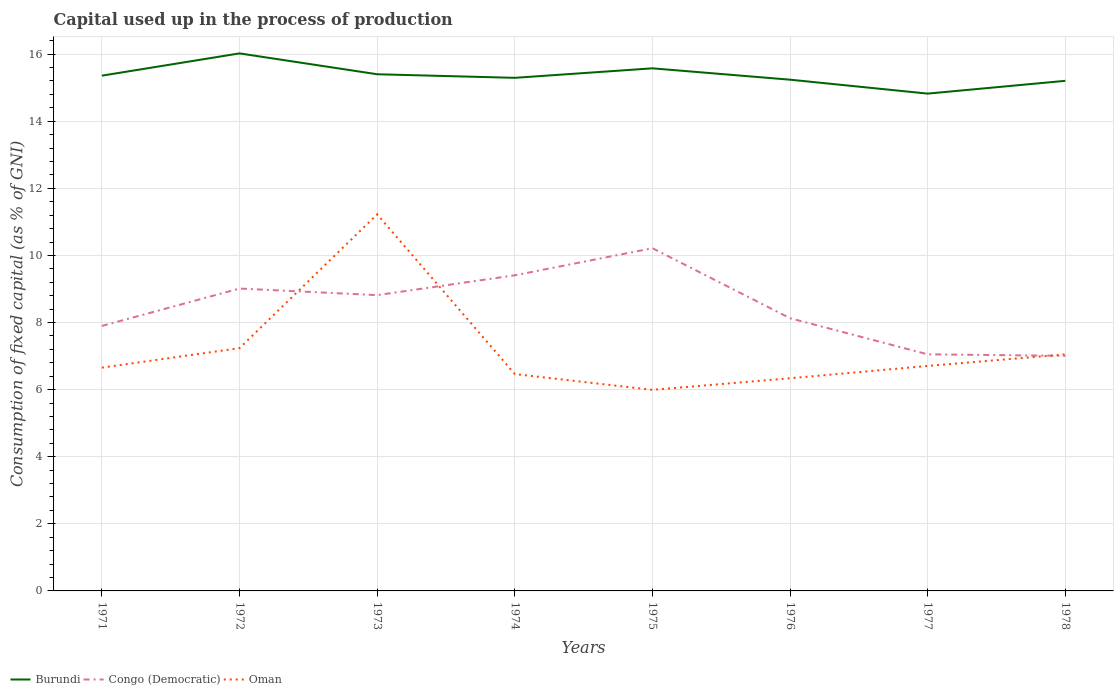How many different coloured lines are there?
Give a very brief answer. 3. Does the line corresponding to Oman intersect with the line corresponding to Congo (Democratic)?
Ensure brevity in your answer.  Yes. Across all years, what is the maximum capital used up in the process of production in Congo (Democratic)?
Give a very brief answer. 7.01. In which year was the capital used up in the process of production in Oman maximum?
Ensure brevity in your answer.  1975. What is the total capital used up in the process of production in Congo (Democratic) in the graph?
Give a very brief answer. -1.4. What is the difference between the highest and the second highest capital used up in the process of production in Congo (Democratic)?
Make the answer very short. 3.21. Is the capital used up in the process of production in Burundi strictly greater than the capital used up in the process of production in Congo (Democratic) over the years?
Provide a short and direct response. No. How many lines are there?
Offer a very short reply. 3. How many years are there in the graph?
Your response must be concise. 8. What is the difference between two consecutive major ticks on the Y-axis?
Offer a very short reply. 2. Are the values on the major ticks of Y-axis written in scientific E-notation?
Provide a succinct answer. No. Does the graph contain any zero values?
Offer a very short reply. No. How many legend labels are there?
Your answer should be compact. 3. How are the legend labels stacked?
Your answer should be compact. Horizontal. What is the title of the graph?
Offer a very short reply. Capital used up in the process of production. What is the label or title of the Y-axis?
Offer a terse response. Consumption of fixed capital (as % of GNI). What is the Consumption of fixed capital (as % of GNI) of Burundi in 1971?
Provide a short and direct response. 15.36. What is the Consumption of fixed capital (as % of GNI) of Congo (Democratic) in 1971?
Provide a short and direct response. 7.9. What is the Consumption of fixed capital (as % of GNI) in Oman in 1971?
Offer a very short reply. 6.66. What is the Consumption of fixed capital (as % of GNI) in Burundi in 1972?
Provide a short and direct response. 16.02. What is the Consumption of fixed capital (as % of GNI) in Congo (Democratic) in 1972?
Provide a short and direct response. 9.01. What is the Consumption of fixed capital (as % of GNI) in Oman in 1972?
Your response must be concise. 7.24. What is the Consumption of fixed capital (as % of GNI) in Burundi in 1973?
Offer a terse response. 15.4. What is the Consumption of fixed capital (as % of GNI) of Congo (Democratic) in 1973?
Your response must be concise. 8.82. What is the Consumption of fixed capital (as % of GNI) of Oman in 1973?
Make the answer very short. 11.23. What is the Consumption of fixed capital (as % of GNI) in Burundi in 1974?
Keep it short and to the point. 15.29. What is the Consumption of fixed capital (as % of GNI) in Congo (Democratic) in 1974?
Your answer should be very brief. 9.41. What is the Consumption of fixed capital (as % of GNI) of Oman in 1974?
Give a very brief answer. 6.46. What is the Consumption of fixed capital (as % of GNI) of Burundi in 1975?
Provide a short and direct response. 15.58. What is the Consumption of fixed capital (as % of GNI) in Congo (Democratic) in 1975?
Your response must be concise. 10.22. What is the Consumption of fixed capital (as % of GNI) in Oman in 1975?
Your answer should be compact. 5.99. What is the Consumption of fixed capital (as % of GNI) of Burundi in 1976?
Your answer should be compact. 15.24. What is the Consumption of fixed capital (as % of GNI) of Congo (Democratic) in 1976?
Provide a succinct answer. 8.13. What is the Consumption of fixed capital (as % of GNI) of Oman in 1976?
Your answer should be very brief. 6.34. What is the Consumption of fixed capital (as % of GNI) of Burundi in 1977?
Keep it short and to the point. 14.82. What is the Consumption of fixed capital (as % of GNI) in Congo (Democratic) in 1977?
Your answer should be very brief. 7.05. What is the Consumption of fixed capital (as % of GNI) of Oman in 1977?
Give a very brief answer. 6.71. What is the Consumption of fixed capital (as % of GNI) in Burundi in 1978?
Provide a succinct answer. 15.2. What is the Consumption of fixed capital (as % of GNI) of Congo (Democratic) in 1978?
Provide a succinct answer. 7.01. What is the Consumption of fixed capital (as % of GNI) of Oman in 1978?
Keep it short and to the point. 7.05. Across all years, what is the maximum Consumption of fixed capital (as % of GNI) in Burundi?
Ensure brevity in your answer.  16.02. Across all years, what is the maximum Consumption of fixed capital (as % of GNI) of Congo (Democratic)?
Keep it short and to the point. 10.22. Across all years, what is the maximum Consumption of fixed capital (as % of GNI) of Oman?
Offer a terse response. 11.23. Across all years, what is the minimum Consumption of fixed capital (as % of GNI) in Burundi?
Your response must be concise. 14.82. Across all years, what is the minimum Consumption of fixed capital (as % of GNI) of Congo (Democratic)?
Your answer should be very brief. 7.01. Across all years, what is the minimum Consumption of fixed capital (as % of GNI) of Oman?
Your answer should be compact. 5.99. What is the total Consumption of fixed capital (as % of GNI) of Burundi in the graph?
Offer a very short reply. 122.92. What is the total Consumption of fixed capital (as % of GNI) of Congo (Democratic) in the graph?
Your response must be concise. 67.54. What is the total Consumption of fixed capital (as % of GNI) of Oman in the graph?
Your answer should be compact. 57.67. What is the difference between the Consumption of fixed capital (as % of GNI) of Burundi in 1971 and that in 1972?
Provide a succinct answer. -0.66. What is the difference between the Consumption of fixed capital (as % of GNI) in Congo (Democratic) in 1971 and that in 1972?
Ensure brevity in your answer.  -1.11. What is the difference between the Consumption of fixed capital (as % of GNI) in Oman in 1971 and that in 1972?
Give a very brief answer. -0.58. What is the difference between the Consumption of fixed capital (as % of GNI) in Burundi in 1971 and that in 1973?
Provide a succinct answer. -0.04. What is the difference between the Consumption of fixed capital (as % of GNI) in Congo (Democratic) in 1971 and that in 1973?
Offer a terse response. -0.92. What is the difference between the Consumption of fixed capital (as % of GNI) of Oman in 1971 and that in 1973?
Keep it short and to the point. -4.57. What is the difference between the Consumption of fixed capital (as % of GNI) in Burundi in 1971 and that in 1974?
Provide a short and direct response. 0.06. What is the difference between the Consumption of fixed capital (as % of GNI) of Congo (Democratic) in 1971 and that in 1974?
Keep it short and to the point. -1.51. What is the difference between the Consumption of fixed capital (as % of GNI) of Oman in 1971 and that in 1974?
Provide a short and direct response. 0.19. What is the difference between the Consumption of fixed capital (as % of GNI) of Burundi in 1971 and that in 1975?
Ensure brevity in your answer.  -0.22. What is the difference between the Consumption of fixed capital (as % of GNI) in Congo (Democratic) in 1971 and that in 1975?
Your response must be concise. -2.32. What is the difference between the Consumption of fixed capital (as % of GNI) in Oman in 1971 and that in 1975?
Keep it short and to the point. 0.66. What is the difference between the Consumption of fixed capital (as % of GNI) of Burundi in 1971 and that in 1976?
Your response must be concise. 0.12. What is the difference between the Consumption of fixed capital (as % of GNI) of Congo (Democratic) in 1971 and that in 1976?
Ensure brevity in your answer.  -0.23. What is the difference between the Consumption of fixed capital (as % of GNI) of Oman in 1971 and that in 1976?
Make the answer very short. 0.32. What is the difference between the Consumption of fixed capital (as % of GNI) of Burundi in 1971 and that in 1977?
Your answer should be compact. 0.54. What is the difference between the Consumption of fixed capital (as % of GNI) of Congo (Democratic) in 1971 and that in 1977?
Give a very brief answer. 0.85. What is the difference between the Consumption of fixed capital (as % of GNI) of Oman in 1971 and that in 1977?
Give a very brief answer. -0.05. What is the difference between the Consumption of fixed capital (as % of GNI) in Burundi in 1971 and that in 1978?
Make the answer very short. 0.15. What is the difference between the Consumption of fixed capital (as % of GNI) of Congo (Democratic) in 1971 and that in 1978?
Offer a terse response. 0.89. What is the difference between the Consumption of fixed capital (as % of GNI) of Oman in 1971 and that in 1978?
Give a very brief answer. -0.4. What is the difference between the Consumption of fixed capital (as % of GNI) of Burundi in 1972 and that in 1973?
Ensure brevity in your answer.  0.62. What is the difference between the Consumption of fixed capital (as % of GNI) in Congo (Democratic) in 1972 and that in 1973?
Provide a short and direct response. 0.2. What is the difference between the Consumption of fixed capital (as % of GNI) of Oman in 1972 and that in 1973?
Offer a terse response. -3.99. What is the difference between the Consumption of fixed capital (as % of GNI) of Burundi in 1972 and that in 1974?
Your response must be concise. 0.73. What is the difference between the Consumption of fixed capital (as % of GNI) of Congo (Democratic) in 1972 and that in 1974?
Offer a terse response. -0.39. What is the difference between the Consumption of fixed capital (as % of GNI) in Oman in 1972 and that in 1974?
Make the answer very short. 0.77. What is the difference between the Consumption of fixed capital (as % of GNI) of Burundi in 1972 and that in 1975?
Make the answer very short. 0.45. What is the difference between the Consumption of fixed capital (as % of GNI) of Congo (Democratic) in 1972 and that in 1975?
Keep it short and to the point. -1.2. What is the difference between the Consumption of fixed capital (as % of GNI) of Oman in 1972 and that in 1975?
Give a very brief answer. 1.24. What is the difference between the Consumption of fixed capital (as % of GNI) of Burundi in 1972 and that in 1976?
Keep it short and to the point. 0.78. What is the difference between the Consumption of fixed capital (as % of GNI) in Congo (Democratic) in 1972 and that in 1976?
Keep it short and to the point. 0.89. What is the difference between the Consumption of fixed capital (as % of GNI) of Oman in 1972 and that in 1976?
Your response must be concise. 0.9. What is the difference between the Consumption of fixed capital (as % of GNI) of Burundi in 1972 and that in 1977?
Provide a succinct answer. 1.2. What is the difference between the Consumption of fixed capital (as % of GNI) of Congo (Democratic) in 1972 and that in 1977?
Ensure brevity in your answer.  1.96. What is the difference between the Consumption of fixed capital (as % of GNI) in Oman in 1972 and that in 1977?
Provide a succinct answer. 0.53. What is the difference between the Consumption of fixed capital (as % of GNI) of Burundi in 1972 and that in 1978?
Offer a very short reply. 0.82. What is the difference between the Consumption of fixed capital (as % of GNI) in Congo (Democratic) in 1972 and that in 1978?
Offer a terse response. 2.01. What is the difference between the Consumption of fixed capital (as % of GNI) in Oman in 1972 and that in 1978?
Provide a succinct answer. 0.19. What is the difference between the Consumption of fixed capital (as % of GNI) in Burundi in 1973 and that in 1974?
Keep it short and to the point. 0.11. What is the difference between the Consumption of fixed capital (as % of GNI) of Congo (Democratic) in 1973 and that in 1974?
Keep it short and to the point. -0.59. What is the difference between the Consumption of fixed capital (as % of GNI) in Oman in 1973 and that in 1974?
Make the answer very short. 4.76. What is the difference between the Consumption of fixed capital (as % of GNI) in Burundi in 1973 and that in 1975?
Ensure brevity in your answer.  -0.18. What is the difference between the Consumption of fixed capital (as % of GNI) in Congo (Democratic) in 1973 and that in 1975?
Give a very brief answer. -1.4. What is the difference between the Consumption of fixed capital (as % of GNI) in Oman in 1973 and that in 1975?
Your answer should be very brief. 5.23. What is the difference between the Consumption of fixed capital (as % of GNI) in Burundi in 1973 and that in 1976?
Your response must be concise. 0.16. What is the difference between the Consumption of fixed capital (as % of GNI) of Congo (Democratic) in 1973 and that in 1976?
Offer a very short reply. 0.69. What is the difference between the Consumption of fixed capital (as % of GNI) in Oman in 1973 and that in 1976?
Your response must be concise. 4.89. What is the difference between the Consumption of fixed capital (as % of GNI) in Burundi in 1973 and that in 1977?
Keep it short and to the point. 0.58. What is the difference between the Consumption of fixed capital (as % of GNI) in Congo (Democratic) in 1973 and that in 1977?
Your response must be concise. 1.76. What is the difference between the Consumption of fixed capital (as % of GNI) of Oman in 1973 and that in 1977?
Ensure brevity in your answer.  4.52. What is the difference between the Consumption of fixed capital (as % of GNI) of Burundi in 1973 and that in 1978?
Provide a short and direct response. 0.2. What is the difference between the Consumption of fixed capital (as % of GNI) of Congo (Democratic) in 1973 and that in 1978?
Offer a very short reply. 1.81. What is the difference between the Consumption of fixed capital (as % of GNI) in Oman in 1973 and that in 1978?
Provide a short and direct response. 4.17. What is the difference between the Consumption of fixed capital (as % of GNI) of Burundi in 1974 and that in 1975?
Provide a succinct answer. -0.28. What is the difference between the Consumption of fixed capital (as % of GNI) of Congo (Democratic) in 1974 and that in 1975?
Your response must be concise. -0.81. What is the difference between the Consumption of fixed capital (as % of GNI) of Oman in 1974 and that in 1975?
Your answer should be compact. 0.47. What is the difference between the Consumption of fixed capital (as % of GNI) of Burundi in 1974 and that in 1976?
Give a very brief answer. 0.06. What is the difference between the Consumption of fixed capital (as % of GNI) in Congo (Democratic) in 1974 and that in 1976?
Your response must be concise. 1.28. What is the difference between the Consumption of fixed capital (as % of GNI) in Oman in 1974 and that in 1976?
Keep it short and to the point. 0.12. What is the difference between the Consumption of fixed capital (as % of GNI) of Burundi in 1974 and that in 1977?
Give a very brief answer. 0.47. What is the difference between the Consumption of fixed capital (as % of GNI) in Congo (Democratic) in 1974 and that in 1977?
Your answer should be very brief. 2.36. What is the difference between the Consumption of fixed capital (as % of GNI) of Oman in 1974 and that in 1977?
Offer a very short reply. -0.24. What is the difference between the Consumption of fixed capital (as % of GNI) in Burundi in 1974 and that in 1978?
Keep it short and to the point. 0.09. What is the difference between the Consumption of fixed capital (as % of GNI) in Congo (Democratic) in 1974 and that in 1978?
Your response must be concise. 2.4. What is the difference between the Consumption of fixed capital (as % of GNI) in Oman in 1974 and that in 1978?
Your answer should be very brief. -0.59. What is the difference between the Consumption of fixed capital (as % of GNI) of Burundi in 1975 and that in 1976?
Offer a terse response. 0.34. What is the difference between the Consumption of fixed capital (as % of GNI) of Congo (Democratic) in 1975 and that in 1976?
Give a very brief answer. 2.09. What is the difference between the Consumption of fixed capital (as % of GNI) in Oman in 1975 and that in 1976?
Make the answer very short. -0.35. What is the difference between the Consumption of fixed capital (as % of GNI) in Burundi in 1975 and that in 1977?
Your answer should be compact. 0.75. What is the difference between the Consumption of fixed capital (as % of GNI) in Congo (Democratic) in 1975 and that in 1977?
Keep it short and to the point. 3.16. What is the difference between the Consumption of fixed capital (as % of GNI) of Oman in 1975 and that in 1977?
Make the answer very short. -0.71. What is the difference between the Consumption of fixed capital (as % of GNI) in Burundi in 1975 and that in 1978?
Your response must be concise. 0.37. What is the difference between the Consumption of fixed capital (as % of GNI) of Congo (Democratic) in 1975 and that in 1978?
Provide a succinct answer. 3.21. What is the difference between the Consumption of fixed capital (as % of GNI) in Oman in 1975 and that in 1978?
Provide a succinct answer. -1.06. What is the difference between the Consumption of fixed capital (as % of GNI) in Burundi in 1976 and that in 1977?
Your response must be concise. 0.41. What is the difference between the Consumption of fixed capital (as % of GNI) in Congo (Democratic) in 1976 and that in 1977?
Your response must be concise. 1.08. What is the difference between the Consumption of fixed capital (as % of GNI) in Oman in 1976 and that in 1977?
Offer a terse response. -0.37. What is the difference between the Consumption of fixed capital (as % of GNI) of Burundi in 1976 and that in 1978?
Ensure brevity in your answer.  0.03. What is the difference between the Consumption of fixed capital (as % of GNI) in Congo (Democratic) in 1976 and that in 1978?
Keep it short and to the point. 1.12. What is the difference between the Consumption of fixed capital (as % of GNI) of Oman in 1976 and that in 1978?
Provide a short and direct response. -0.71. What is the difference between the Consumption of fixed capital (as % of GNI) in Burundi in 1977 and that in 1978?
Make the answer very short. -0.38. What is the difference between the Consumption of fixed capital (as % of GNI) in Congo (Democratic) in 1977 and that in 1978?
Make the answer very short. 0.05. What is the difference between the Consumption of fixed capital (as % of GNI) of Oman in 1977 and that in 1978?
Make the answer very short. -0.35. What is the difference between the Consumption of fixed capital (as % of GNI) of Burundi in 1971 and the Consumption of fixed capital (as % of GNI) of Congo (Democratic) in 1972?
Provide a succinct answer. 6.35. What is the difference between the Consumption of fixed capital (as % of GNI) of Burundi in 1971 and the Consumption of fixed capital (as % of GNI) of Oman in 1972?
Your answer should be very brief. 8.12. What is the difference between the Consumption of fixed capital (as % of GNI) in Congo (Democratic) in 1971 and the Consumption of fixed capital (as % of GNI) in Oman in 1972?
Your response must be concise. 0.66. What is the difference between the Consumption of fixed capital (as % of GNI) of Burundi in 1971 and the Consumption of fixed capital (as % of GNI) of Congo (Democratic) in 1973?
Give a very brief answer. 6.54. What is the difference between the Consumption of fixed capital (as % of GNI) of Burundi in 1971 and the Consumption of fixed capital (as % of GNI) of Oman in 1973?
Make the answer very short. 4.13. What is the difference between the Consumption of fixed capital (as % of GNI) in Congo (Democratic) in 1971 and the Consumption of fixed capital (as % of GNI) in Oman in 1973?
Provide a succinct answer. -3.33. What is the difference between the Consumption of fixed capital (as % of GNI) in Burundi in 1971 and the Consumption of fixed capital (as % of GNI) in Congo (Democratic) in 1974?
Your response must be concise. 5.95. What is the difference between the Consumption of fixed capital (as % of GNI) of Burundi in 1971 and the Consumption of fixed capital (as % of GNI) of Oman in 1974?
Provide a short and direct response. 8.89. What is the difference between the Consumption of fixed capital (as % of GNI) in Congo (Democratic) in 1971 and the Consumption of fixed capital (as % of GNI) in Oman in 1974?
Offer a terse response. 1.43. What is the difference between the Consumption of fixed capital (as % of GNI) in Burundi in 1971 and the Consumption of fixed capital (as % of GNI) in Congo (Democratic) in 1975?
Your answer should be compact. 5.14. What is the difference between the Consumption of fixed capital (as % of GNI) in Burundi in 1971 and the Consumption of fixed capital (as % of GNI) in Oman in 1975?
Give a very brief answer. 9.37. What is the difference between the Consumption of fixed capital (as % of GNI) in Congo (Democratic) in 1971 and the Consumption of fixed capital (as % of GNI) in Oman in 1975?
Give a very brief answer. 1.91. What is the difference between the Consumption of fixed capital (as % of GNI) in Burundi in 1971 and the Consumption of fixed capital (as % of GNI) in Congo (Democratic) in 1976?
Make the answer very short. 7.23. What is the difference between the Consumption of fixed capital (as % of GNI) in Burundi in 1971 and the Consumption of fixed capital (as % of GNI) in Oman in 1976?
Ensure brevity in your answer.  9.02. What is the difference between the Consumption of fixed capital (as % of GNI) in Congo (Democratic) in 1971 and the Consumption of fixed capital (as % of GNI) in Oman in 1976?
Your answer should be compact. 1.56. What is the difference between the Consumption of fixed capital (as % of GNI) in Burundi in 1971 and the Consumption of fixed capital (as % of GNI) in Congo (Democratic) in 1977?
Provide a succinct answer. 8.31. What is the difference between the Consumption of fixed capital (as % of GNI) of Burundi in 1971 and the Consumption of fixed capital (as % of GNI) of Oman in 1977?
Keep it short and to the point. 8.65. What is the difference between the Consumption of fixed capital (as % of GNI) in Congo (Democratic) in 1971 and the Consumption of fixed capital (as % of GNI) in Oman in 1977?
Provide a short and direct response. 1.19. What is the difference between the Consumption of fixed capital (as % of GNI) in Burundi in 1971 and the Consumption of fixed capital (as % of GNI) in Congo (Democratic) in 1978?
Make the answer very short. 8.35. What is the difference between the Consumption of fixed capital (as % of GNI) in Burundi in 1971 and the Consumption of fixed capital (as % of GNI) in Oman in 1978?
Ensure brevity in your answer.  8.31. What is the difference between the Consumption of fixed capital (as % of GNI) in Congo (Democratic) in 1971 and the Consumption of fixed capital (as % of GNI) in Oman in 1978?
Offer a terse response. 0.85. What is the difference between the Consumption of fixed capital (as % of GNI) in Burundi in 1972 and the Consumption of fixed capital (as % of GNI) in Congo (Democratic) in 1973?
Offer a terse response. 7.21. What is the difference between the Consumption of fixed capital (as % of GNI) of Burundi in 1972 and the Consumption of fixed capital (as % of GNI) of Oman in 1973?
Give a very brief answer. 4.8. What is the difference between the Consumption of fixed capital (as % of GNI) of Congo (Democratic) in 1972 and the Consumption of fixed capital (as % of GNI) of Oman in 1973?
Your answer should be very brief. -2.21. What is the difference between the Consumption of fixed capital (as % of GNI) in Burundi in 1972 and the Consumption of fixed capital (as % of GNI) in Congo (Democratic) in 1974?
Keep it short and to the point. 6.61. What is the difference between the Consumption of fixed capital (as % of GNI) in Burundi in 1972 and the Consumption of fixed capital (as % of GNI) in Oman in 1974?
Your answer should be compact. 9.56. What is the difference between the Consumption of fixed capital (as % of GNI) of Congo (Democratic) in 1972 and the Consumption of fixed capital (as % of GNI) of Oman in 1974?
Offer a terse response. 2.55. What is the difference between the Consumption of fixed capital (as % of GNI) of Burundi in 1972 and the Consumption of fixed capital (as % of GNI) of Congo (Democratic) in 1975?
Provide a succinct answer. 5.81. What is the difference between the Consumption of fixed capital (as % of GNI) in Burundi in 1972 and the Consumption of fixed capital (as % of GNI) in Oman in 1975?
Offer a terse response. 10.03. What is the difference between the Consumption of fixed capital (as % of GNI) in Congo (Democratic) in 1972 and the Consumption of fixed capital (as % of GNI) in Oman in 1975?
Your answer should be very brief. 3.02. What is the difference between the Consumption of fixed capital (as % of GNI) in Burundi in 1972 and the Consumption of fixed capital (as % of GNI) in Congo (Democratic) in 1976?
Offer a terse response. 7.89. What is the difference between the Consumption of fixed capital (as % of GNI) in Burundi in 1972 and the Consumption of fixed capital (as % of GNI) in Oman in 1976?
Your answer should be compact. 9.68. What is the difference between the Consumption of fixed capital (as % of GNI) in Congo (Democratic) in 1972 and the Consumption of fixed capital (as % of GNI) in Oman in 1976?
Ensure brevity in your answer.  2.67. What is the difference between the Consumption of fixed capital (as % of GNI) in Burundi in 1972 and the Consumption of fixed capital (as % of GNI) in Congo (Democratic) in 1977?
Give a very brief answer. 8.97. What is the difference between the Consumption of fixed capital (as % of GNI) of Burundi in 1972 and the Consumption of fixed capital (as % of GNI) of Oman in 1977?
Your answer should be very brief. 9.32. What is the difference between the Consumption of fixed capital (as % of GNI) in Congo (Democratic) in 1972 and the Consumption of fixed capital (as % of GNI) in Oman in 1977?
Keep it short and to the point. 2.31. What is the difference between the Consumption of fixed capital (as % of GNI) in Burundi in 1972 and the Consumption of fixed capital (as % of GNI) in Congo (Democratic) in 1978?
Your response must be concise. 9.02. What is the difference between the Consumption of fixed capital (as % of GNI) in Burundi in 1972 and the Consumption of fixed capital (as % of GNI) in Oman in 1978?
Your answer should be compact. 8.97. What is the difference between the Consumption of fixed capital (as % of GNI) of Congo (Democratic) in 1972 and the Consumption of fixed capital (as % of GNI) of Oman in 1978?
Your answer should be very brief. 1.96. What is the difference between the Consumption of fixed capital (as % of GNI) of Burundi in 1973 and the Consumption of fixed capital (as % of GNI) of Congo (Democratic) in 1974?
Ensure brevity in your answer.  5.99. What is the difference between the Consumption of fixed capital (as % of GNI) in Burundi in 1973 and the Consumption of fixed capital (as % of GNI) in Oman in 1974?
Provide a short and direct response. 8.94. What is the difference between the Consumption of fixed capital (as % of GNI) in Congo (Democratic) in 1973 and the Consumption of fixed capital (as % of GNI) in Oman in 1974?
Your answer should be compact. 2.35. What is the difference between the Consumption of fixed capital (as % of GNI) in Burundi in 1973 and the Consumption of fixed capital (as % of GNI) in Congo (Democratic) in 1975?
Your answer should be very brief. 5.19. What is the difference between the Consumption of fixed capital (as % of GNI) of Burundi in 1973 and the Consumption of fixed capital (as % of GNI) of Oman in 1975?
Keep it short and to the point. 9.41. What is the difference between the Consumption of fixed capital (as % of GNI) in Congo (Democratic) in 1973 and the Consumption of fixed capital (as % of GNI) in Oman in 1975?
Your answer should be compact. 2.82. What is the difference between the Consumption of fixed capital (as % of GNI) of Burundi in 1973 and the Consumption of fixed capital (as % of GNI) of Congo (Democratic) in 1976?
Provide a short and direct response. 7.27. What is the difference between the Consumption of fixed capital (as % of GNI) of Burundi in 1973 and the Consumption of fixed capital (as % of GNI) of Oman in 1976?
Offer a very short reply. 9.06. What is the difference between the Consumption of fixed capital (as % of GNI) in Congo (Democratic) in 1973 and the Consumption of fixed capital (as % of GNI) in Oman in 1976?
Your answer should be compact. 2.48. What is the difference between the Consumption of fixed capital (as % of GNI) in Burundi in 1973 and the Consumption of fixed capital (as % of GNI) in Congo (Democratic) in 1977?
Ensure brevity in your answer.  8.35. What is the difference between the Consumption of fixed capital (as % of GNI) of Burundi in 1973 and the Consumption of fixed capital (as % of GNI) of Oman in 1977?
Offer a terse response. 8.7. What is the difference between the Consumption of fixed capital (as % of GNI) in Congo (Democratic) in 1973 and the Consumption of fixed capital (as % of GNI) in Oman in 1977?
Your answer should be compact. 2.11. What is the difference between the Consumption of fixed capital (as % of GNI) in Burundi in 1973 and the Consumption of fixed capital (as % of GNI) in Congo (Democratic) in 1978?
Offer a terse response. 8.39. What is the difference between the Consumption of fixed capital (as % of GNI) of Burundi in 1973 and the Consumption of fixed capital (as % of GNI) of Oman in 1978?
Keep it short and to the point. 8.35. What is the difference between the Consumption of fixed capital (as % of GNI) of Congo (Democratic) in 1973 and the Consumption of fixed capital (as % of GNI) of Oman in 1978?
Ensure brevity in your answer.  1.77. What is the difference between the Consumption of fixed capital (as % of GNI) of Burundi in 1974 and the Consumption of fixed capital (as % of GNI) of Congo (Democratic) in 1975?
Ensure brevity in your answer.  5.08. What is the difference between the Consumption of fixed capital (as % of GNI) of Burundi in 1974 and the Consumption of fixed capital (as % of GNI) of Oman in 1975?
Offer a terse response. 9.3. What is the difference between the Consumption of fixed capital (as % of GNI) in Congo (Democratic) in 1974 and the Consumption of fixed capital (as % of GNI) in Oman in 1975?
Your answer should be very brief. 3.41. What is the difference between the Consumption of fixed capital (as % of GNI) in Burundi in 1974 and the Consumption of fixed capital (as % of GNI) in Congo (Democratic) in 1976?
Ensure brevity in your answer.  7.17. What is the difference between the Consumption of fixed capital (as % of GNI) in Burundi in 1974 and the Consumption of fixed capital (as % of GNI) in Oman in 1976?
Your answer should be compact. 8.95. What is the difference between the Consumption of fixed capital (as % of GNI) in Congo (Democratic) in 1974 and the Consumption of fixed capital (as % of GNI) in Oman in 1976?
Your answer should be compact. 3.07. What is the difference between the Consumption of fixed capital (as % of GNI) in Burundi in 1974 and the Consumption of fixed capital (as % of GNI) in Congo (Democratic) in 1977?
Provide a succinct answer. 8.24. What is the difference between the Consumption of fixed capital (as % of GNI) in Burundi in 1974 and the Consumption of fixed capital (as % of GNI) in Oman in 1977?
Offer a very short reply. 8.59. What is the difference between the Consumption of fixed capital (as % of GNI) in Congo (Democratic) in 1974 and the Consumption of fixed capital (as % of GNI) in Oman in 1977?
Your answer should be very brief. 2.7. What is the difference between the Consumption of fixed capital (as % of GNI) in Burundi in 1974 and the Consumption of fixed capital (as % of GNI) in Congo (Democratic) in 1978?
Offer a very short reply. 8.29. What is the difference between the Consumption of fixed capital (as % of GNI) of Burundi in 1974 and the Consumption of fixed capital (as % of GNI) of Oman in 1978?
Your response must be concise. 8.24. What is the difference between the Consumption of fixed capital (as % of GNI) of Congo (Democratic) in 1974 and the Consumption of fixed capital (as % of GNI) of Oman in 1978?
Your answer should be very brief. 2.36. What is the difference between the Consumption of fixed capital (as % of GNI) of Burundi in 1975 and the Consumption of fixed capital (as % of GNI) of Congo (Democratic) in 1976?
Provide a succinct answer. 7.45. What is the difference between the Consumption of fixed capital (as % of GNI) in Burundi in 1975 and the Consumption of fixed capital (as % of GNI) in Oman in 1976?
Provide a succinct answer. 9.24. What is the difference between the Consumption of fixed capital (as % of GNI) in Congo (Democratic) in 1975 and the Consumption of fixed capital (as % of GNI) in Oman in 1976?
Your answer should be compact. 3.88. What is the difference between the Consumption of fixed capital (as % of GNI) of Burundi in 1975 and the Consumption of fixed capital (as % of GNI) of Congo (Democratic) in 1977?
Your answer should be very brief. 8.53. What is the difference between the Consumption of fixed capital (as % of GNI) of Burundi in 1975 and the Consumption of fixed capital (as % of GNI) of Oman in 1977?
Your answer should be compact. 8.87. What is the difference between the Consumption of fixed capital (as % of GNI) of Congo (Democratic) in 1975 and the Consumption of fixed capital (as % of GNI) of Oman in 1977?
Provide a succinct answer. 3.51. What is the difference between the Consumption of fixed capital (as % of GNI) in Burundi in 1975 and the Consumption of fixed capital (as % of GNI) in Congo (Democratic) in 1978?
Provide a short and direct response. 8.57. What is the difference between the Consumption of fixed capital (as % of GNI) of Burundi in 1975 and the Consumption of fixed capital (as % of GNI) of Oman in 1978?
Make the answer very short. 8.53. What is the difference between the Consumption of fixed capital (as % of GNI) of Congo (Democratic) in 1975 and the Consumption of fixed capital (as % of GNI) of Oman in 1978?
Keep it short and to the point. 3.16. What is the difference between the Consumption of fixed capital (as % of GNI) in Burundi in 1976 and the Consumption of fixed capital (as % of GNI) in Congo (Democratic) in 1977?
Provide a short and direct response. 8.19. What is the difference between the Consumption of fixed capital (as % of GNI) in Burundi in 1976 and the Consumption of fixed capital (as % of GNI) in Oman in 1977?
Keep it short and to the point. 8.53. What is the difference between the Consumption of fixed capital (as % of GNI) of Congo (Democratic) in 1976 and the Consumption of fixed capital (as % of GNI) of Oman in 1977?
Your answer should be compact. 1.42. What is the difference between the Consumption of fixed capital (as % of GNI) in Burundi in 1976 and the Consumption of fixed capital (as % of GNI) in Congo (Democratic) in 1978?
Your answer should be compact. 8.23. What is the difference between the Consumption of fixed capital (as % of GNI) of Burundi in 1976 and the Consumption of fixed capital (as % of GNI) of Oman in 1978?
Make the answer very short. 8.19. What is the difference between the Consumption of fixed capital (as % of GNI) in Congo (Democratic) in 1976 and the Consumption of fixed capital (as % of GNI) in Oman in 1978?
Give a very brief answer. 1.08. What is the difference between the Consumption of fixed capital (as % of GNI) of Burundi in 1977 and the Consumption of fixed capital (as % of GNI) of Congo (Democratic) in 1978?
Give a very brief answer. 7.82. What is the difference between the Consumption of fixed capital (as % of GNI) of Burundi in 1977 and the Consumption of fixed capital (as % of GNI) of Oman in 1978?
Provide a short and direct response. 7.77. What is the difference between the Consumption of fixed capital (as % of GNI) of Congo (Democratic) in 1977 and the Consumption of fixed capital (as % of GNI) of Oman in 1978?
Your answer should be compact. 0. What is the average Consumption of fixed capital (as % of GNI) of Burundi per year?
Offer a very short reply. 15.37. What is the average Consumption of fixed capital (as % of GNI) of Congo (Democratic) per year?
Your response must be concise. 8.44. What is the average Consumption of fixed capital (as % of GNI) in Oman per year?
Provide a succinct answer. 7.21. In the year 1971, what is the difference between the Consumption of fixed capital (as % of GNI) in Burundi and Consumption of fixed capital (as % of GNI) in Congo (Democratic)?
Ensure brevity in your answer.  7.46. In the year 1971, what is the difference between the Consumption of fixed capital (as % of GNI) of Burundi and Consumption of fixed capital (as % of GNI) of Oman?
Your response must be concise. 8.7. In the year 1971, what is the difference between the Consumption of fixed capital (as % of GNI) in Congo (Democratic) and Consumption of fixed capital (as % of GNI) in Oman?
Offer a terse response. 1.24. In the year 1972, what is the difference between the Consumption of fixed capital (as % of GNI) in Burundi and Consumption of fixed capital (as % of GNI) in Congo (Democratic)?
Give a very brief answer. 7.01. In the year 1972, what is the difference between the Consumption of fixed capital (as % of GNI) in Burundi and Consumption of fixed capital (as % of GNI) in Oman?
Ensure brevity in your answer.  8.79. In the year 1972, what is the difference between the Consumption of fixed capital (as % of GNI) of Congo (Democratic) and Consumption of fixed capital (as % of GNI) of Oman?
Ensure brevity in your answer.  1.78. In the year 1973, what is the difference between the Consumption of fixed capital (as % of GNI) of Burundi and Consumption of fixed capital (as % of GNI) of Congo (Democratic)?
Offer a very short reply. 6.58. In the year 1973, what is the difference between the Consumption of fixed capital (as % of GNI) of Burundi and Consumption of fixed capital (as % of GNI) of Oman?
Make the answer very short. 4.18. In the year 1973, what is the difference between the Consumption of fixed capital (as % of GNI) in Congo (Democratic) and Consumption of fixed capital (as % of GNI) in Oman?
Your answer should be very brief. -2.41. In the year 1974, what is the difference between the Consumption of fixed capital (as % of GNI) in Burundi and Consumption of fixed capital (as % of GNI) in Congo (Democratic)?
Keep it short and to the point. 5.89. In the year 1974, what is the difference between the Consumption of fixed capital (as % of GNI) in Burundi and Consumption of fixed capital (as % of GNI) in Oman?
Provide a succinct answer. 8.83. In the year 1974, what is the difference between the Consumption of fixed capital (as % of GNI) in Congo (Democratic) and Consumption of fixed capital (as % of GNI) in Oman?
Your answer should be compact. 2.94. In the year 1975, what is the difference between the Consumption of fixed capital (as % of GNI) in Burundi and Consumption of fixed capital (as % of GNI) in Congo (Democratic)?
Give a very brief answer. 5.36. In the year 1975, what is the difference between the Consumption of fixed capital (as % of GNI) in Burundi and Consumption of fixed capital (as % of GNI) in Oman?
Give a very brief answer. 9.58. In the year 1975, what is the difference between the Consumption of fixed capital (as % of GNI) in Congo (Democratic) and Consumption of fixed capital (as % of GNI) in Oman?
Provide a succinct answer. 4.22. In the year 1976, what is the difference between the Consumption of fixed capital (as % of GNI) in Burundi and Consumption of fixed capital (as % of GNI) in Congo (Democratic)?
Offer a terse response. 7.11. In the year 1976, what is the difference between the Consumption of fixed capital (as % of GNI) of Burundi and Consumption of fixed capital (as % of GNI) of Oman?
Ensure brevity in your answer.  8.9. In the year 1976, what is the difference between the Consumption of fixed capital (as % of GNI) of Congo (Democratic) and Consumption of fixed capital (as % of GNI) of Oman?
Your answer should be very brief. 1.79. In the year 1977, what is the difference between the Consumption of fixed capital (as % of GNI) in Burundi and Consumption of fixed capital (as % of GNI) in Congo (Democratic)?
Make the answer very short. 7.77. In the year 1977, what is the difference between the Consumption of fixed capital (as % of GNI) of Burundi and Consumption of fixed capital (as % of GNI) of Oman?
Give a very brief answer. 8.12. In the year 1977, what is the difference between the Consumption of fixed capital (as % of GNI) in Congo (Democratic) and Consumption of fixed capital (as % of GNI) in Oman?
Ensure brevity in your answer.  0.35. In the year 1978, what is the difference between the Consumption of fixed capital (as % of GNI) in Burundi and Consumption of fixed capital (as % of GNI) in Congo (Democratic)?
Make the answer very short. 8.2. In the year 1978, what is the difference between the Consumption of fixed capital (as % of GNI) in Burundi and Consumption of fixed capital (as % of GNI) in Oman?
Provide a short and direct response. 8.15. In the year 1978, what is the difference between the Consumption of fixed capital (as % of GNI) in Congo (Democratic) and Consumption of fixed capital (as % of GNI) in Oman?
Your response must be concise. -0.04. What is the ratio of the Consumption of fixed capital (as % of GNI) of Burundi in 1971 to that in 1972?
Your answer should be compact. 0.96. What is the ratio of the Consumption of fixed capital (as % of GNI) in Congo (Democratic) in 1971 to that in 1972?
Your response must be concise. 0.88. What is the ratio of the Consumption of fixed capital (as % of GNI) in Oman in 1971 to that in 1972?
Ensure brevity in your answer.  0.92. What is the ratio of the Consumption of fixed capital (as % of GNI) of Burundi in 1971 to that in 1973?
Your answer should be compact. 1. What is the ratio of the Consumption of fixed capital (as % of GNI) in Congo (Democratic) in 1971 to that in 1973?
Your response must be concise. 0.9. What is the ratio of the Consumption of fixed capital (as % of GNI) in Oman in 1971 to that in 1973?
Offer a terse response. 0.59. What is the ratio of the Consumption of fixed capital (as % of GNI) of Burundi in 1971 to that in 1974?
Offer a very short reply. 1. What is the ratio of the Consumption of fixed capital (as % of GNI) in Congo (Democratic) in 1971 to that in 1974?
Provide a succinct answer. 0.84. What is the ratio of the Consumption of fixed capital (as % of GNI) of Oman in 1971 to that in 1974?
Your answer should be very brief. 1.03. What is the ratio of the Consumption of fixed capital (as % of GNI) of Burundi in 1971 to that in 1975?
Provide a succinct answer. 0.99. What is the ratio of the Consumption of fixed capital (as % of GNI) in Congo (Democratic) in 1971 to that in 1975?
Your answer should be compact. 0.77. What is the ratio of the Consumption of fixed capital (as % of GNI) of Oman in 1971 to that in 1975?
Your response must be concise. 1.11. What is the ratio of the Consumption of fixed capital (as % of GNI) of Burundi in 1971 to that in 1976?
Your answer should be compact. 1.01. What is the ratio of the Consumption of fixed capital (as % of GNI) in Congo (Democratic) in 1971 to that in 1976?
Offer a very short reply. 0.97. What is the ratio of the Consumption of fixed capital (as % of GNI) in Oman in 1971 to that in 1976?
Your answer should be compact. 1.05. What is the ratio of the Consumption of fixed capital (as % of GNI) of Burundi in 1971 to that in 1977?
Offer a very short reply. 1.04. What is the ratio of the Consumption of fixed capital (as % of GNI) in Congo (Democratic) in 1971 to that in 1977?
Your response must be concise. 1.12. What is the ratio of the Consumption of fixed capital (as % of GNI) in Oman in 1971 to that in 1977?
Make the answer very short. 0.99. What is the ratio of the Consumption of fixed capital (as % of GNI) in Burundi in 1971 to that in 1978?
Provide a succinct answer. 1.01. What is the ratio of the Consumption of fixed capital (as % of GNI) in Congo (Democratic) in 1971 to that in 1978?
Your response must be concise. 1.13. What is the ratio of the Consumption of fixed capital (as % of GNI) of Oman in 1971 to that in 1978?
Ensure brevity in your answer.  0.94. What is the ratio of the Consumption of fixed capital (as % of GNI) of Burundi in 1972 to that in 1973?
Keep it short and to the point. 1.04. What is the ratio of the Consumption of fixed capital (as % of GNI) of Congo (Democratic) in 1972 to that in 1973?
Provide a short and direct response. 1.02. What is the ratio of the Consumption of fixed capital (as % of GNI) in Oman in 1972 to that in 1973?
Your answer should be compact. 0.64. What is the ratio of the Consumption of fixed capital (as % of GNI) in Burundi in 1972 to that in 1974?
Make the answer very short. 1.05. What is the ratio of the Consumption of fixed capital (as % of GNI) in Congo (Democratic) in 1972 to that in 1974?
Ensure brevity in your answer.  0.96. What is the ratio of the Consumption of fixed capital (as % of GNI) in Oman in 1972 to that in 1974?
Your answer should be very brief. 1.12. What is the ratio of the Consumption of fixed capital (as % of GNI) in Burundi in 1972 to that in 1975?
Provide a short and direct response. 1.03. What is the ratio of the Consumption of fixed capital (as % of GNI) in Congo (Democratic) in 1972 to that in 1975?
Provide a short and direct response. 0.88. What is the ratio of the Consumption of fixed capital (as % of GNI) in Oman in 1972 to that in 1975?
Your answer should be compact. 1.21. What is the ratio of the Consumption of fixed capital (as % of GNI) in Burundi in 1972 to that in 1976?
Your answer should be very brief. 1.05. What is the ratio of the Consumption of fixed capital (as % of GNI) of Congo (Democratic) in 1972 to that in 1976?
Your answer should be compact. 1.11. What is the ratio of the Consumption of fixed capital (as % of GNI) of Oman in 1972 to that in 1976?
Provide a succinct answer. 1.14. What is the ratio of the Consumption of fixed capital (as % of GNI) of Burundi in 1972 to that in 1977?
Your response must be concise. 1.08. What is the ratio of the Consumption of fixed capital (as % of GNI) of Congo (Democratic) in 1972 to that in 1977?
Provide a short and direct response. 1.28. What is the ratio of the Consumption of fixed capital (as % of GNI) in Oman in 1972 to that in 1977?
Offer a very short reply. 1.08. What is the ratio of the Consumption of fixed capital (as % of GNI) in Burundi in 1972 to that in 1978?
Your answer should be compact. 1.05. What is the ratio of the Consumption of fixed capital (as % of GNI) in Congo (Democratic) in 1972 to that in 1978?
Your answer should be very brief. 1.29. What is the ratio of the Consumption of fixed capital (as % of GNI) of Oman in 1972 to that in 1978?
Provide a succinct answer. 1.03. What is the ratio of the Consumption of fixed capital (as % of GNI) in Burundi in 1973 to that in 1974?
Offer a terse response. 1.01. What is the ratio of the Consumption of fixed capital (as % of GNI) of Congo (Democratic) in 1973 to that in 1974?
Provide a short and direct response. 0.94. What is the ratio of the Consumption of fixed capital (as % of GNI) in Oman in 1973 to that in 1974?
Ensure brevity in your answer.  1.74. What is the ratio of the Consumption of fixed capital (as % of GNI) of Burundi in 1973 to that in 1975?
Your answer should be compact. 0.99. What is the ratio of the Consumption of fixed capital (as % of GNI) in Congo (Democratic) in 1973 to that in 1975?
Offer a very short reply. 0.86. What is the ratio of the Consumption of fixed capital (as % of GNI) in Oman in 1973 to that in 1975?
Your answer should be very brief. 1.87. What is the ratio of the Consumption of fixed capital (as % of GNI) of Burundi in 1973 to that in 1976?
Make the answer very short. 1.01. What is the ratio of the Consumption of fixed capital (as % of GNI) of Congo (Democratic) in 1973 to that in 1976?
Your answer should be very brief. 1.08. What is the ratio of the Consumption of fixed capital (as % of GNI) of Oman in 1973 to that in 1976?
Provide a short and direct response. 1.77. What is the ratio of the Consumption of fixed capital (as % of GNI) in Burundi in 1973 to that in 1977?
Your answer should be compact. 1.04. What is the ratio of the Consumption of fixed capital (as % of GNI) of Congo (Democratic) in 1973 to that in 1977?
Give a very brief answer. 1.25. What is the ratio of the Consumption of fixed capital (as % of GNI) of Oman in 1973 to that in 1977?
Offer a very short reply. 1.67. What is the ratio of the Consumption of fixed capital (as % of GNI) in Burundi in 1973 to that in 1978?
Make the answer very short. 1.01. What is the ratio of the Consumption of fixed capital (as % of GNI) in Congo (Democratic) in 1973 to that in 1978?
Offer a terse response. 1.26. What is the ratio of the Consumption of fixed capital (as % of GNI) in Oman in 1973 to that in 1978?
Provide a succinct answer. 1.59. What is the ratio of the Consumption of fixed capital (as % of GNI) in Burundi in 1974 to that in 1975?
Your answer should be compact. 0.98. What is the ratio of the Consumption of fixed capital (as % of GNI) in Congo (Democratic) in 1974 to that in 1975?
Provide a short and direct response. 0.92. What is the ratio of the Consumption of fixed capital (as % of GNI) in Oman in 1974 to that in 1975?
Ensure brevity in your answer.  1.08. What is the ratio of the Consumption of fixed capital (as % of GNI) in Burundi in 1974 to that in 1976?
Your answer should be compact. 1. What is the ratio of the Consumption of fixed capital (as % of GNI) in Congo (Democratic) in 1974 to that in 1976?
Keep it short and to the point. 1.16. What is the ratio of the Consumption of fixed capital (as % of GNI) in Oman in 1974 to that in 1976?
Keep it short and to the point. 1.02. What is the ratio of the Consumption of fixed capital (as % of GNI) of Burundi in 1974 to that in 1977?
Offer a very short reply. 1.03. What is the ratio of the Consumption of fixed capital (as % of GNI) in Congo (Democratic) in 1974 to that in 1977?
Give a very brief answer. 1.33. What is the ratio of the Consumption of fixed capital (as % of GNI) of Oman in 1974 to that in 1977?
Provide a succinct answer. 0.96. What is the ratio of the Consumption of fixed capital (as % of GNI) of Burundi in 1974 to that in 1978?
Your answer should be very brief. 1.01. What is the ratio of the Consumption of fixed capital (as % of GNI) in Congo (Democratic) in 1974 to that in 1978?
Ensure brevity in your answer.  1.34. What is the ratio of the Consumption of fixed capital (as % of GNI) in Oman in 1974 to that in 1978?
Give a very brief answer. 0.92. What is the ratio of the Consumption of fixed capital (as % of GNI) of Burundi in 1975 to that in 1976?
Your response must be concise. 1.02. What is the ratio of the Consumption of fixed capital (as % of GNI) in Congo (Democratic) in 1975 to that in 1976?
Your answer should be compact. 1.26. What is the ratio of the Consumption of fixed capital (as % of GNI) of Oman in 1975 to that in 1976?
Make the answer very short. 0.95. What is the ratio of the Consumption of fixed capital (as % of GNI) in Burundi in 1975 to that in 1977?
Ensure brevity in your answer.  1.05. What is the ratio of the Consumption of fixed capital (as % of GNI) in Congo (Democratic) in 1975 to that in 1977?
Provide a short and direct response. 1.45. What is the ratio of the Consumption of fixed capital (as % of GNI) in Oman in 1975 to that in 1977?
Make the answer very short. 0.89. What is the ratio of the Consumption of fixed capital (as % of GNI) of Burundi in 1975 to that in 1978?
Your answer should be compact. 1.02. What is the ratio of the Consumption of fixed capital (as % of GNI) in Congo (Democratic) in 1975 to that in 1978?
Ensure brevity in your answer.  1.46. What is the ratio of the Consumption of fixed capital (as % of GNI) in Oman in 1975 to that in 1978?
Offer a very short reply. 0.85. What is the ratio of the Consumption of fixed capital (as % of GNI) in Burundi in 1976 to that in 1977?
Ensure brevity in your answer.  1.03. What is the ratio of the Consumption of fixed capital (as % of GNI) of Congo (Democratic) in 1976 to that in 1977?
Give a very brief answer. 1.15. What is the ratio of the Consumption of fixed capital (as % of GNI) of Oman in 1976 to that in 1977?
Keep it short and to the point. 0.95. What is the ratio of the Consumption of fixed capital (as % of GNI) of Burundi in 1976 to that in 1978?
Your answer should be very brief. 1. What is the ratio of the Consumption of fixed capital (as % of GNI) in Congo (Democratic) in 1976 to that in 1978?
Provide a succinct answer. 1.16. What is the ratio of the Consumption of fixed capital (as % of GNI) of Oman in 1976 to that in 1978?
Your response must be concise. 0.9. What is the ratio of the Consumption of fixed capital (as % of GNI) in Burundi in 1977 to that in 1978?
Offer a terse response. 0.97. What is the ratio of the Consumption of fixed capital (as % of GNI) of Oman in 1977 to that in 1978?
Offer a very short reply. 0.95. What is the difference between the highest and the second highest Consumption of fixed capital (as % of GNI) of Burundi?
Provide a succinct answer. 0.45. What is the difference between the highest and the second highest Consumption of fixed capital (as % of GNI) of Congo (Democratic)?
Your response must be concise. 0.81. What is the difference between the highest and the second highest Consumption of fixed capital (as % of GNI) of Oman?
Provide a short and direct response. 3.99. What is the difference between the highest and the lowest Consumption of fixed capital (as % of GNI) in Burundi?
Your answer should be very brief. 1.2. What is the difference between the highest and the lowest Consumption of fixed capital (as % of GNI) of Congo (Democratic)?
Offer a terse response. 3.21. What is the difference between the highest and the lowest Consumption of fixed capital (as % of GNI) in Oman?
Provide a short and direct response. 5.23. 